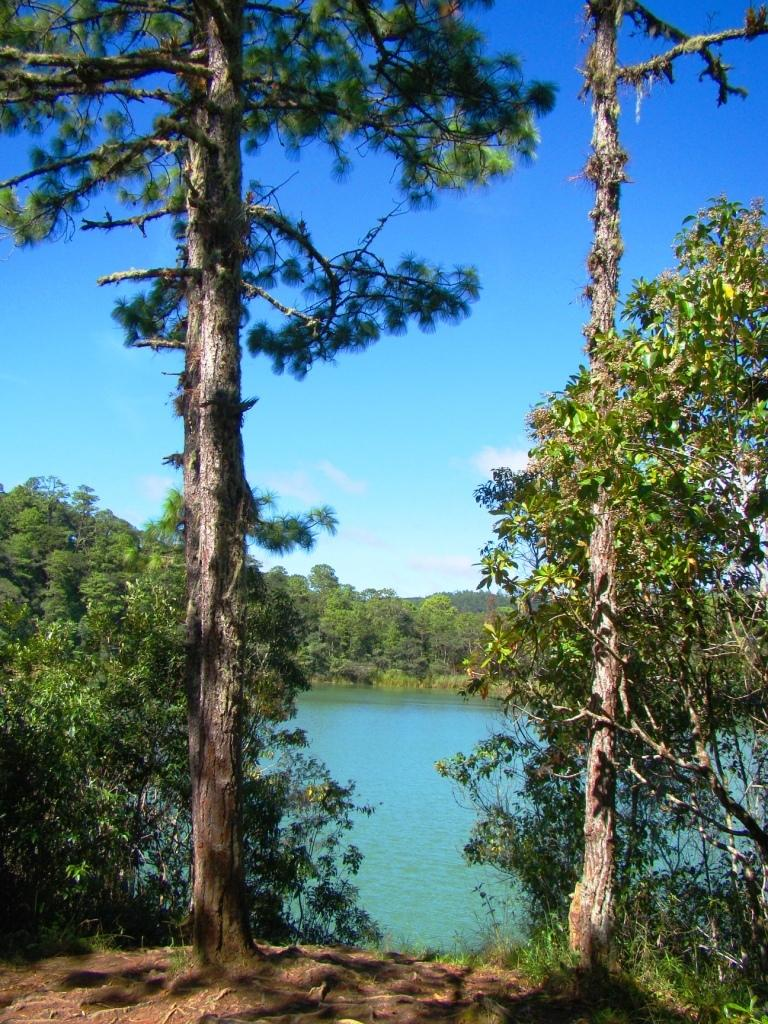What is the primary element visible in the image? There is water in the image. What type of vegetation can be seen in the image? There are many trees in the image. What can be seen in the background of the image? There are clouds visible in the background of the image, and the sky is blue. How many ants can be seen resting on the leaves of the trees in the image? There are no ants visible in the image, and therefore no ants can be seen resting on the leaves of the trees. 